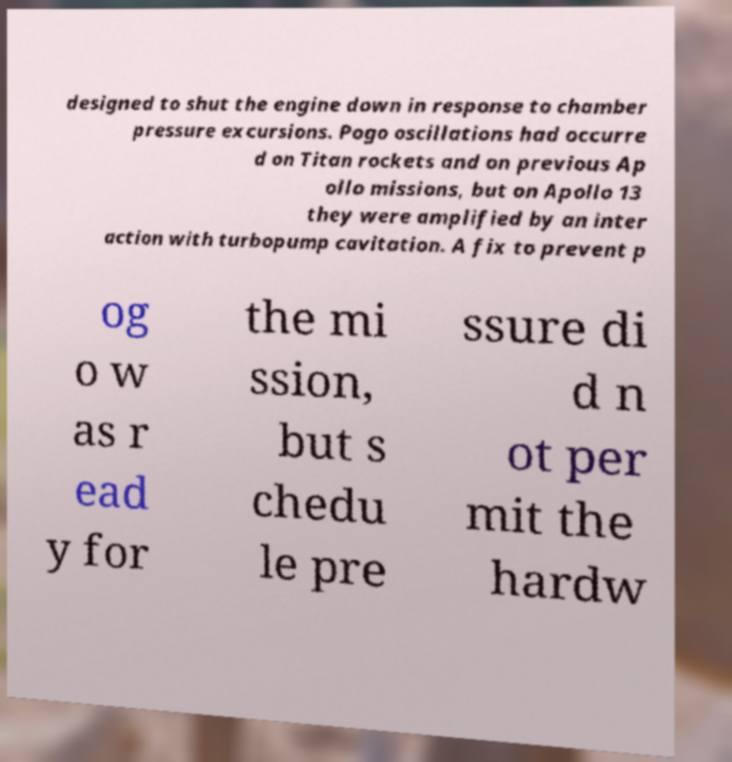Could you extract and type out the text from this image? designed to shut the engine down in response to chamber pressure excursions. Pogo oscillations had occurre d on Titan rockets and on previous Ap ollo missions, but on Apollo 13 they were amplified by an inter action with turbopump cavitation. A fix to prevent p og o w as r ead y for the mi ssion, but s chedu le pre ssure di d n ot per mit the hardw 